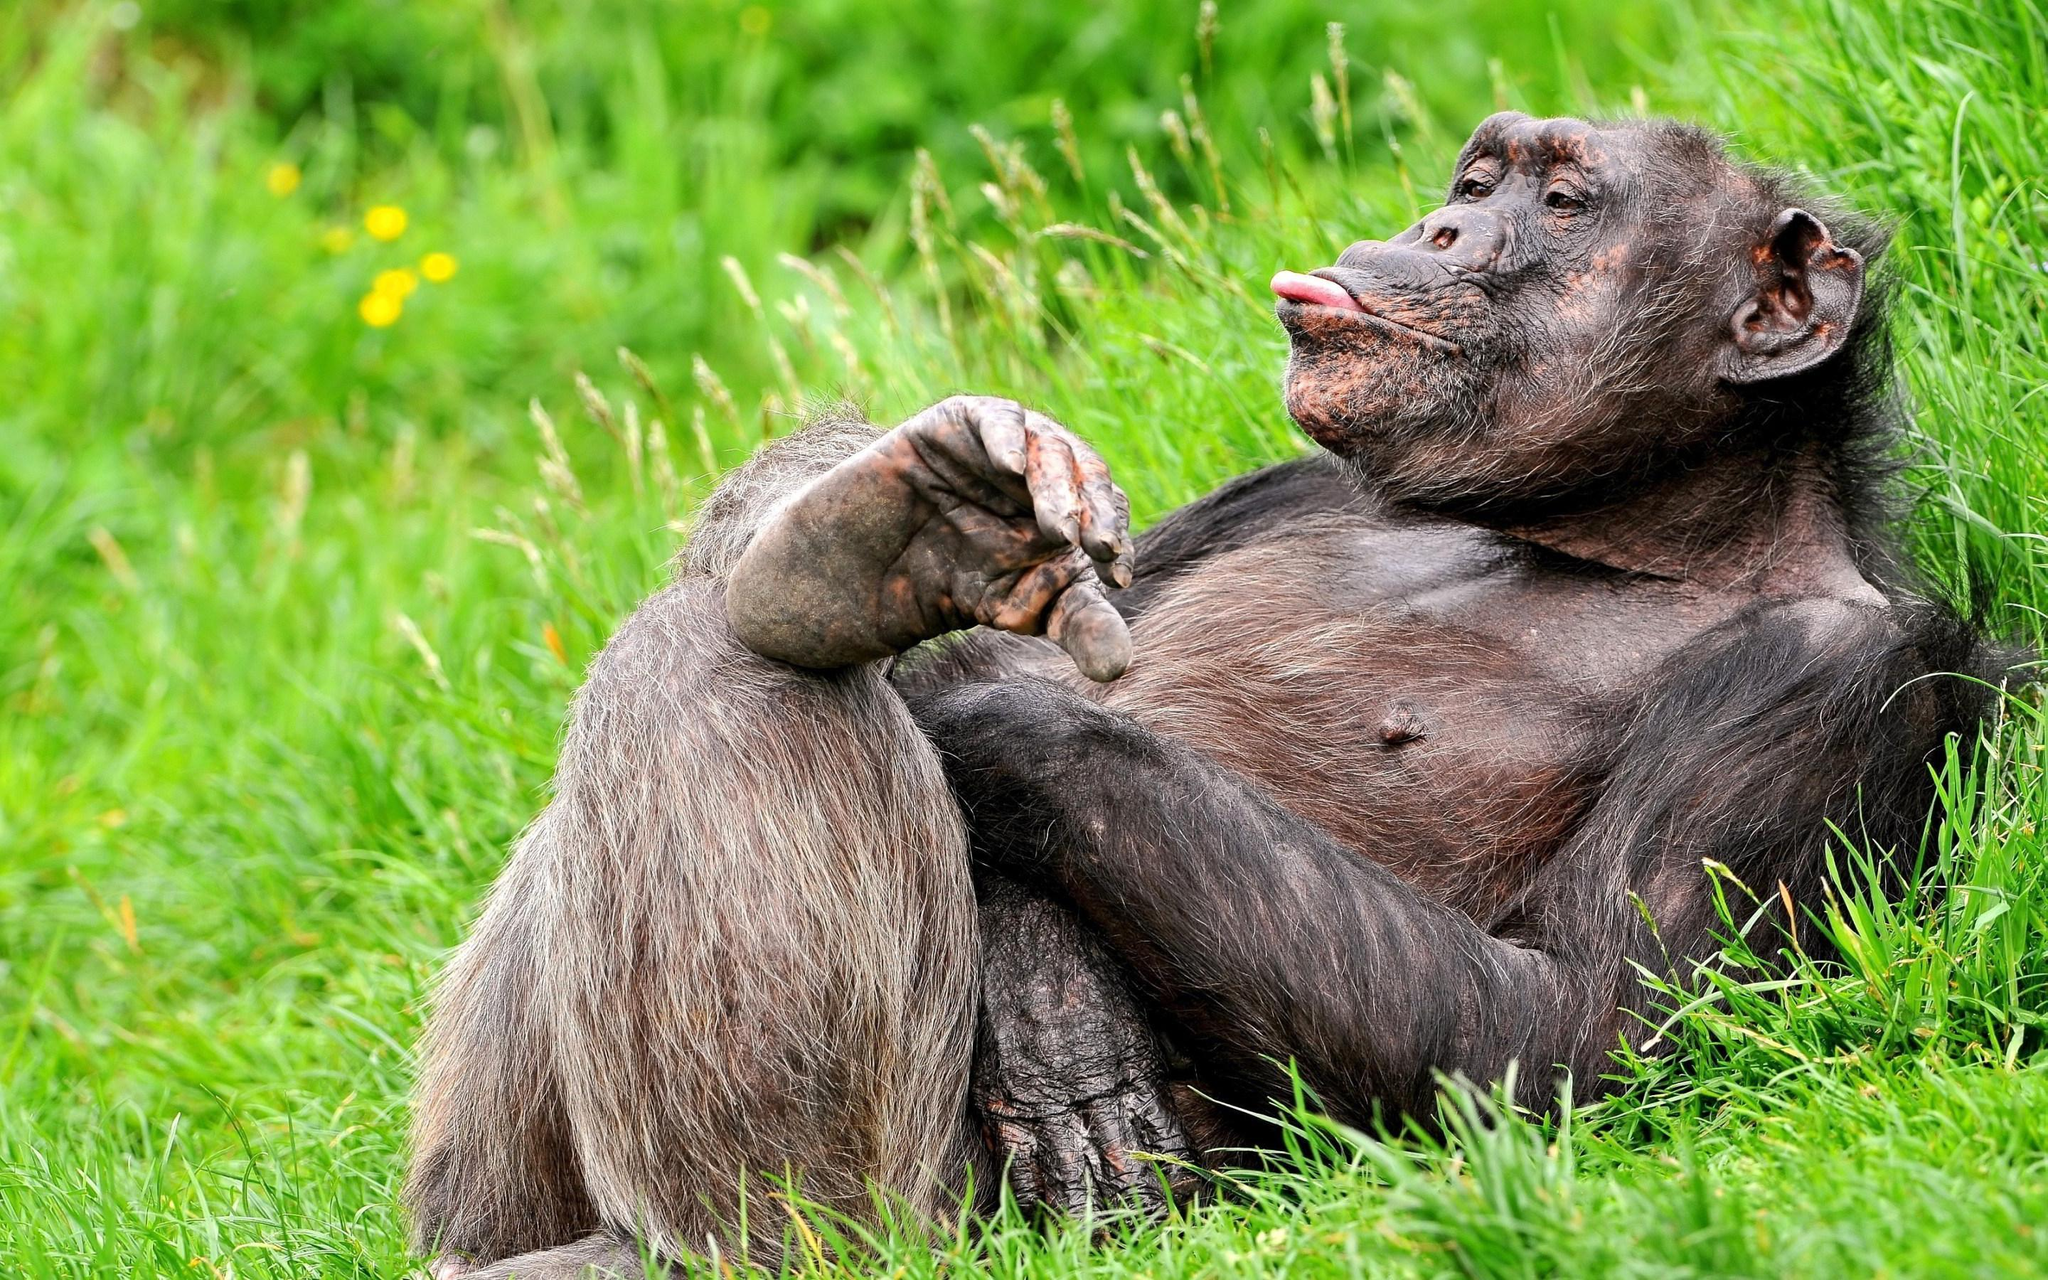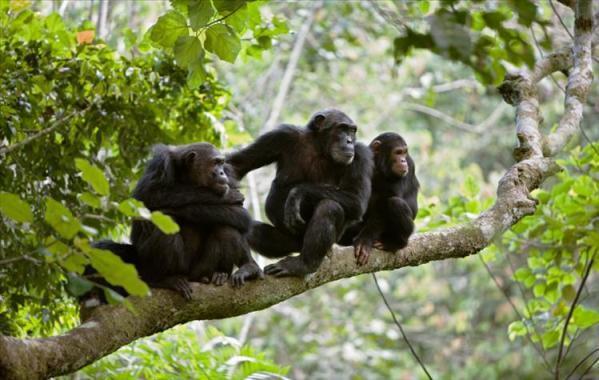The first image is the image on the left, the second image is the image on the right. Considering the images on both sides, is "The image on the left contains three chimpanzees." valid? Answer yes or no. No. The first image is the image on the left, the second image is the image on the right. For the images displayed, is the sentence "In one of the image there are 3 chimpanzees on a branch." factually correct? Answer yes or no. Yes. 